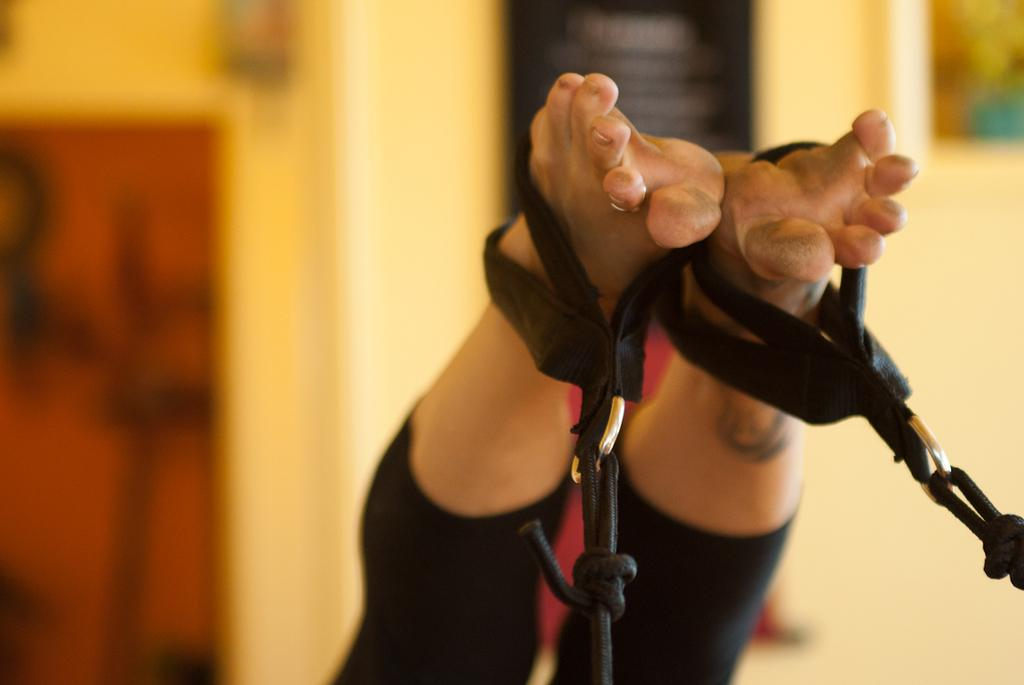What is the main subject of the image? There is a person in the image. What is the person's position in relation to the black color objects? The person's legs are hanging from the black color objects. What do the black color objects resemble? The black color objects resemble chains. How would you describe the background of the image? The background of the image is blurry. What type of dock can be seen in the image? There is no dock present in the image. What emotion does the person in the image express? The image does not show any clear expression of emotion, so it cannot be determined from the image. 